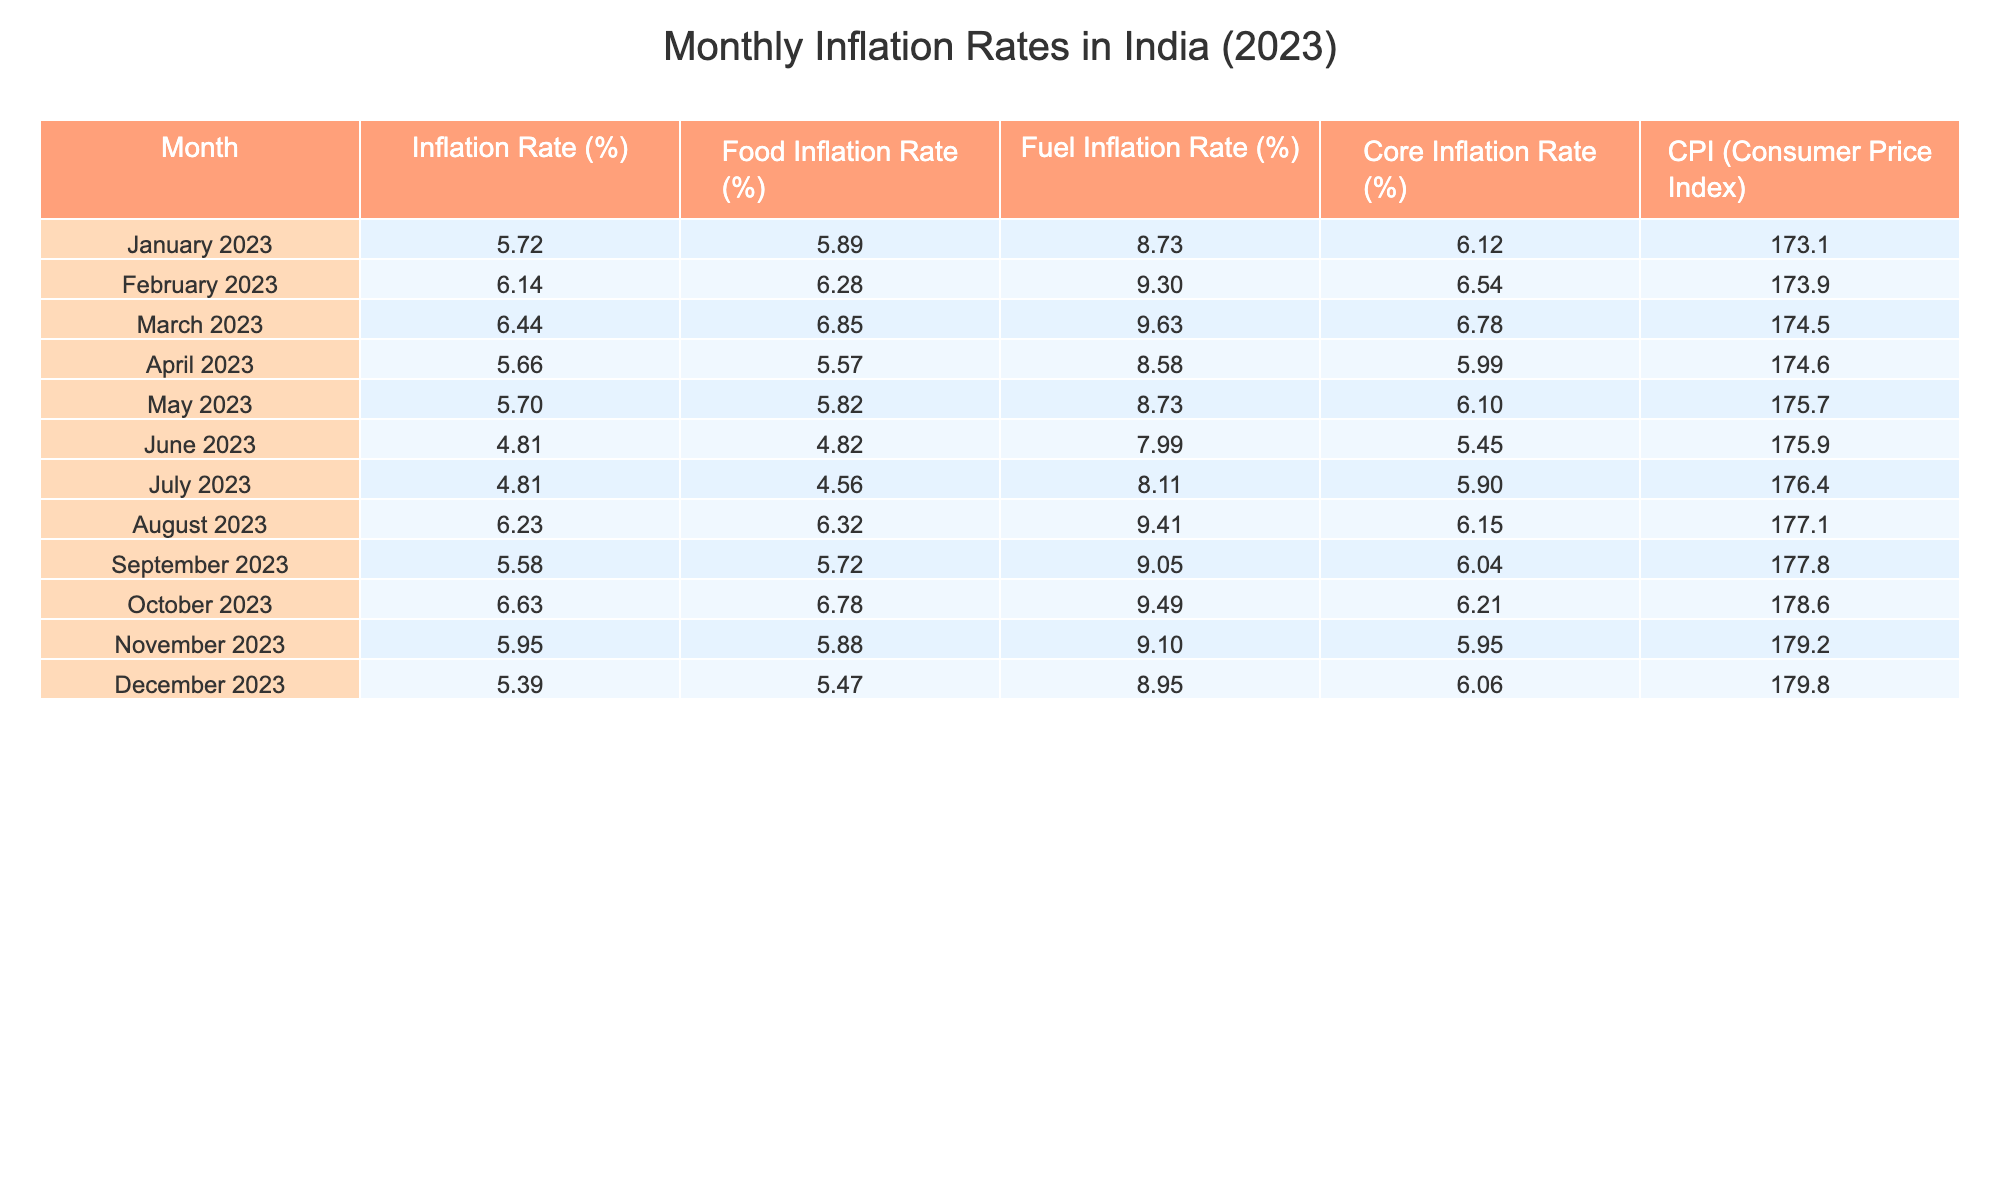What is the inflation rate in June 2023? Referring to the table, the inflation rate for June 2023 is directly listed under the Inflation Rate (%) column. It shows a value of 4.81%.
Answer: 4.81% Which month had the highest food inflation rate in 2023? Looking through the Food Inflation Rate (%) column, the highest value is 6.85%, which occurs in March 2023.
Answer: March 2023 What was the average inflation rate for the second quarter (April to June) of 2023? The inflation rates for April, May, and June are 5.66%, 5.70%, and 4.81%, respectively. Summing them gives 5.66 + 5.70 + 4.81 = 16.17. Dividing by 3 (the number of months) yields an average of 16.17 / 3 = 5.39%.
Answer: 5.39% Is the fuel inflation rate lower in July 2023 than in June 2023? The fuel inflation rate for July 2023 is 8.11%, and for June 2023, it is 7.99%. Since 8.11% is greater than 7.99%, the answer is no.
Answer: No What is the difference in inflation rates between October 2023 and December 2023? The inflation rate for October 2023 is 6.63%, and for December 2023, it is 5.39%. The difference is calculated by subtracting December's rate from October's: 6.63 - 5.39 = 1.24%.
Answer: 1.24% Which month had a core inflation rate that is higher than the average core inflation rate for the year? The average core inflation rate calculated from all months adds up to 6.09% (based on the individual monthly values). In the months of January (6.12%), February (6.54%), March (6.78%), August (6.15%), and October (6.21%), they all exceed this average. Thus, the months listed have higher core inflation.
Answer: January, February, March, August, October How did the CPI change from January 2023 to August 2023? The CPI for January 2023 is listed as 173.1, and for August 2023, it is 177.1. The change is 177.1 - 173.1 = 4.0. Therefore, the CPI increased by 4.0 points during this period.
Answer: 4.0 Was there any month in 2023 without food inflation exceeding 6%? Referring to the Food Inflation Rate (%) column, the months of June (4.82%) and July (4.56%) had food inflation rates below 6%. Thus, there were two months where the food inflation did not exceed 6%.
Answer: Yes What is the median inflation rate of the year? To find the median, we first sort the inflation rates: 4.81, 4.81, 5.39, 5.66, 5.70, 5.72, 5.95, 6.14, 6.23, 6.44, 6.63. Since there are 12 months, the median is the average of the 6th and 7th values: (5.72 + 5.95)/2 = 5.845%.
Answer: 5.845% 